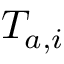Convert formula to latex. <formula><loc_0><loc_0><loc_500><loc_500>T _ { a , i }</formula> 